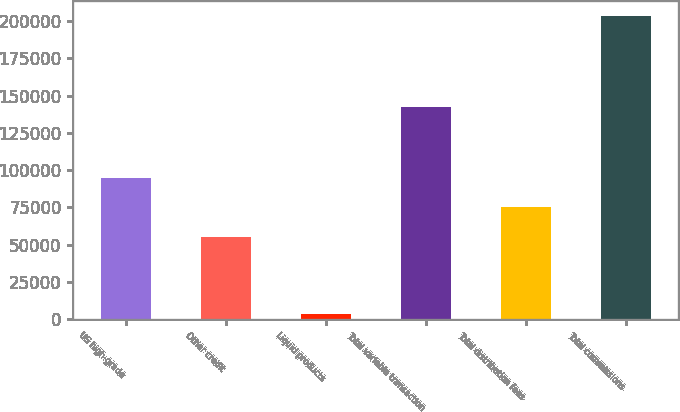Convert chart to OTSL. <chart><loc_0><loc_0><loc_500><loc_500><bar_chart><fcel>US high-grade<fcel>Other credit<fcel>Liquid products<fcel>Total variable transaction<fcel>Total distribution fees<fcel>Total commissions<nl><fcel>95090.4<fcel>55046<fcel>3430<fcel>142293<fcel>75068.2<fcel>203652<nl></chart> 